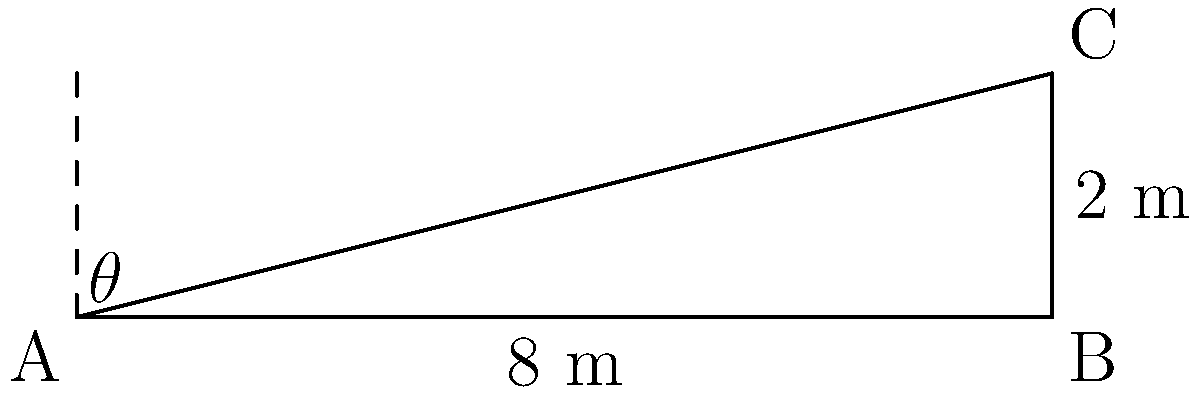As a musician setting up for an outdoor concert, you need to calculate the angle of inclination for a sloped stage. The stage platform is 8 meters long and rises 2 meters from one end to the other. What is the angle of inclination (θ) of the stage? To find the angle of inclination, we can use the trigonometric function tangent. Here's how:

1) In the right triangle formed by the stage, we have:
   - Adjacent side (base) = 8 meters
   - Opposite side (height) = 2 meters

2) The tangent of an angle is defined as the ratio of the opposite side to the adjacent side:

   $$\tan(\theta) = \frac{\text{opposite}}{\text{adjacent}} = \frac{2}{8} = \frac{1}{4}$$

3) To find θ, we need to use the inverse tangent (arctan or tan^(-1)):

   $$\theta = \arctan(\frac{1}{4})$$

4) Using a calculator or trigonometric tables:

   $$\theta \approx 14.04^\circ$$

5) Rounding to the nearest degree:

   $$\theta \approx 14^\circ$$

This angle represents the slope of the stage, which is crucial for setting up equipment and ensuring proper acoustics for your performance.
Answer: $14^\circ$ 